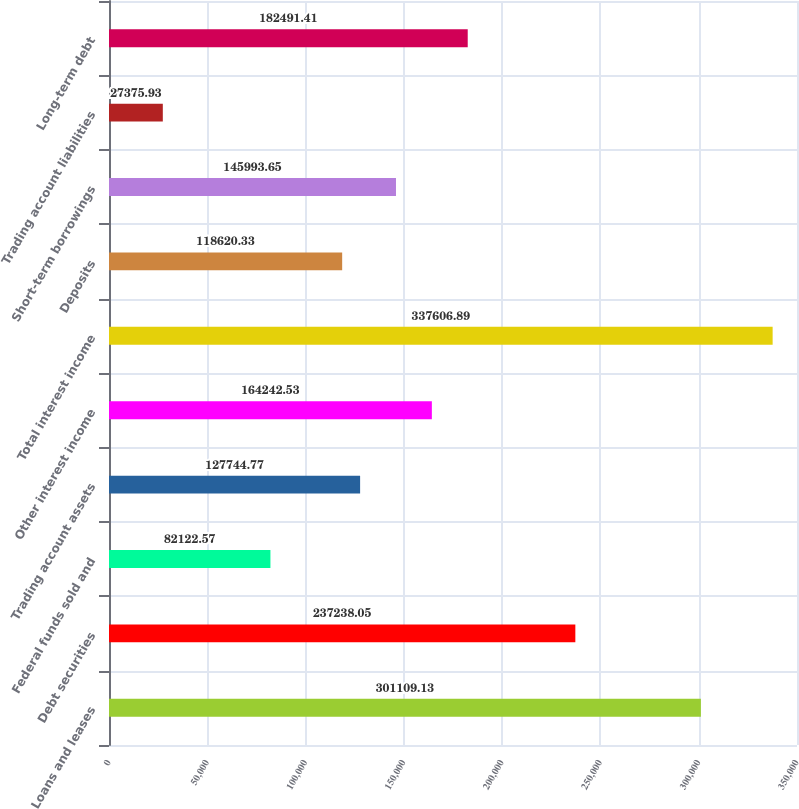Convert chart to OTSL. <chart><loc_0><loc_0><loc_500><loc_500><bar_chart><fcel>Loans and leases<fcel>Debt securities<fcel>Federal funds sold and<fcel>Trading account assets<fcel>Other interest income<fcel>Total interest income<fcel>Deposits<fcel>Short-term borrowings<fcel>Trading account liabilities<fcel>Long-term debt<nl><fcel>301109<fcel>237238<fcel>82122.6<fcel>127745<fcel>164243<fcel>337607<fcel>118620<fcel>145994<fcel>27375.9<fcel>182491<nl></chart> 